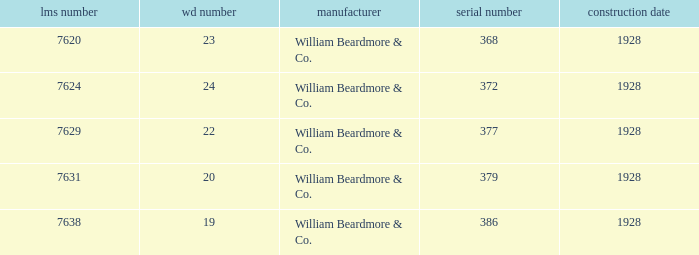Name the total number of wd number for lms number being 7638 1.0. 